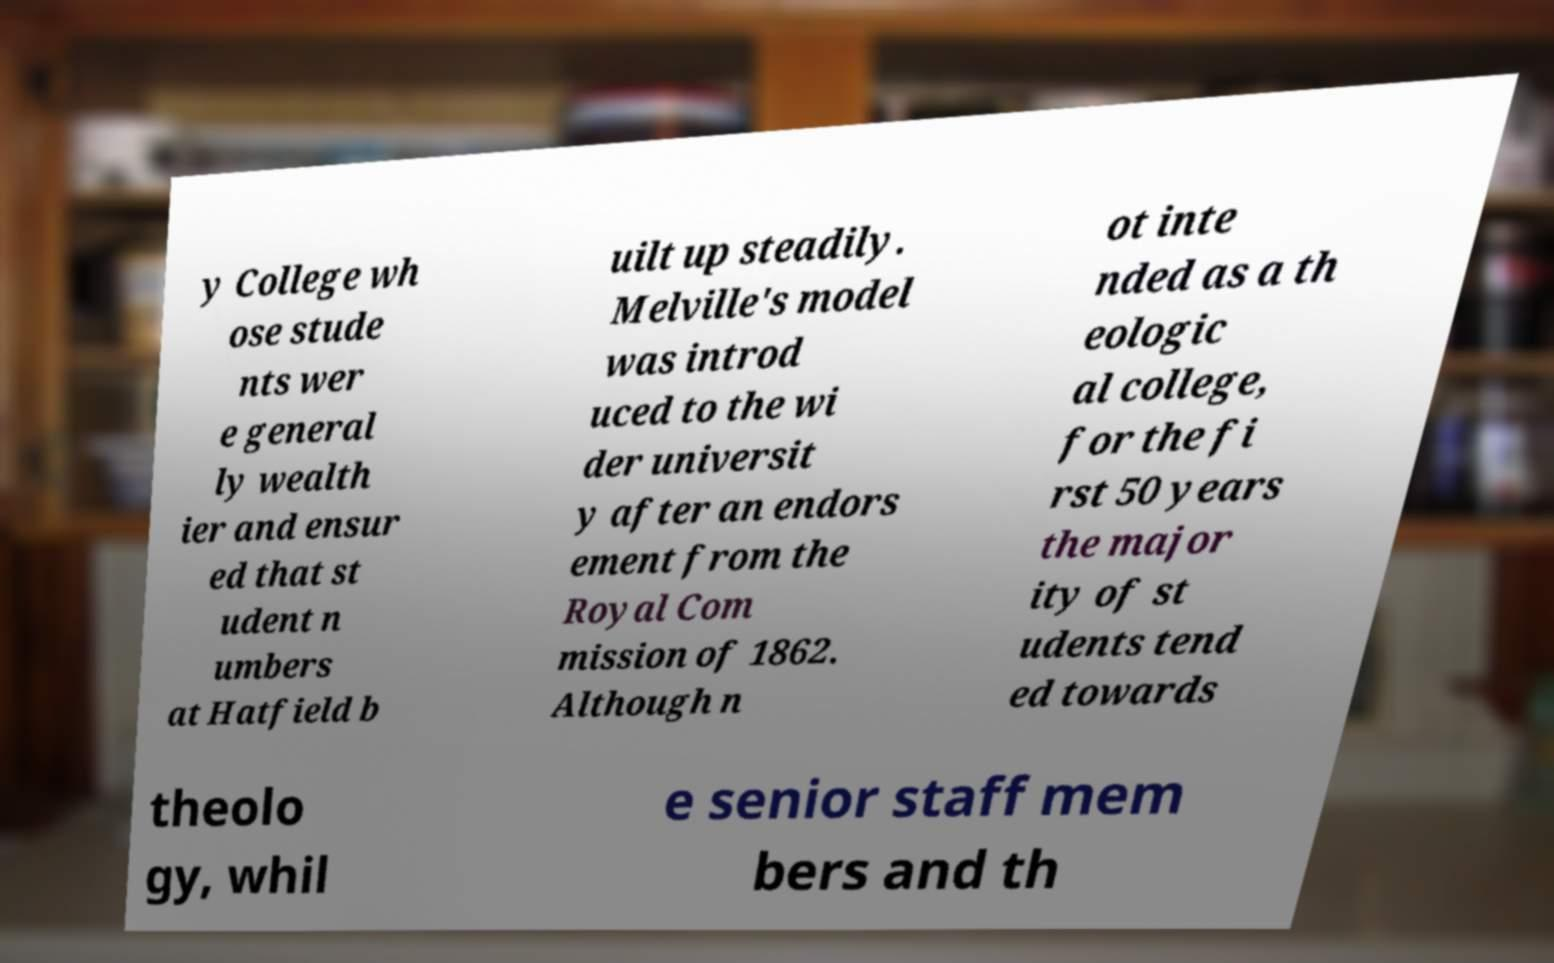For documentation purposes, I need the text within this image transcribed. Could you provide that? y College wh ose stude nts wer e general ly wealth ier and ensur ed that st udent n umbers at Hatfield b uilt up steadily. Melville's model was introd uced to the wi der universit y after an endors ement from the Royal Com mission of 1862. Although n ot inte nded as a th eologic al college, for the fi rst 50 years the major ity of st udents tend ed towards theolo gy, whil e senior staff mem bers and th 